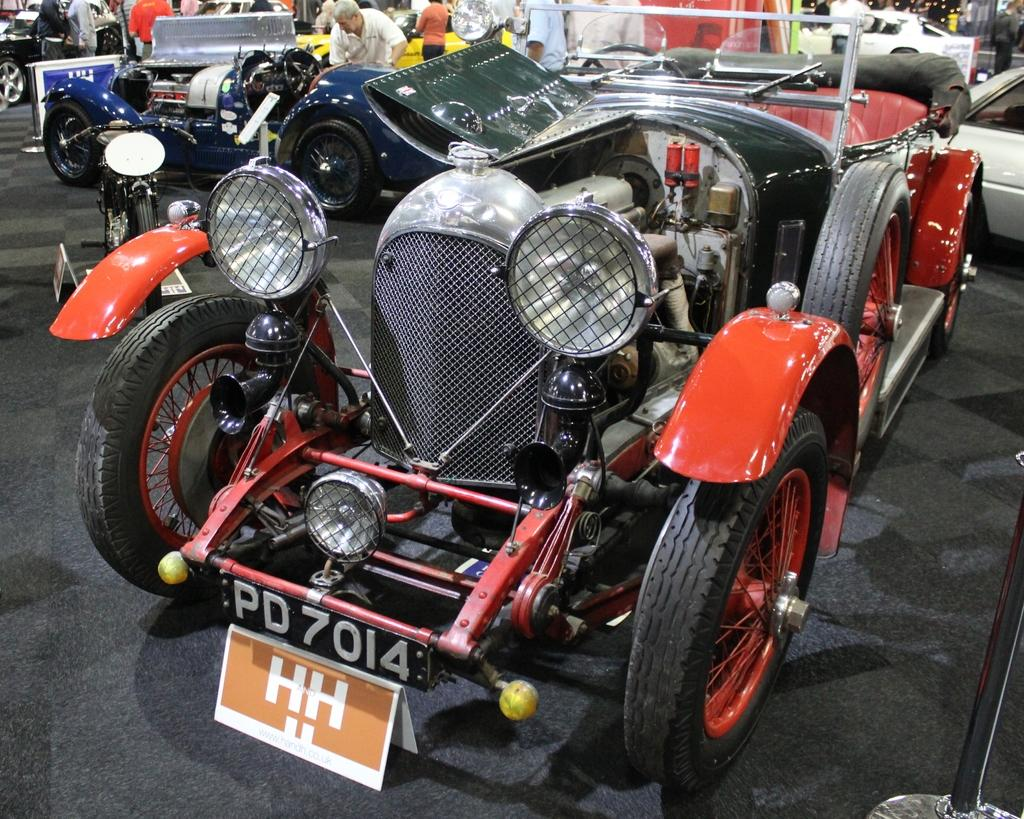What is the person in the image doing? The person is riding a bicycle. Is the person wearing any protective gear in the image? Yes, the person is wearing a helmet. What type of railway is visible in the image? There is no railway present in the image; it features a person riding a bicycle. Can you tell me how many roses the person's brother gave them in the image? There is no mention of a brother or roses in the image; it only shows a person riding a bicycle and wearing a helmet. 